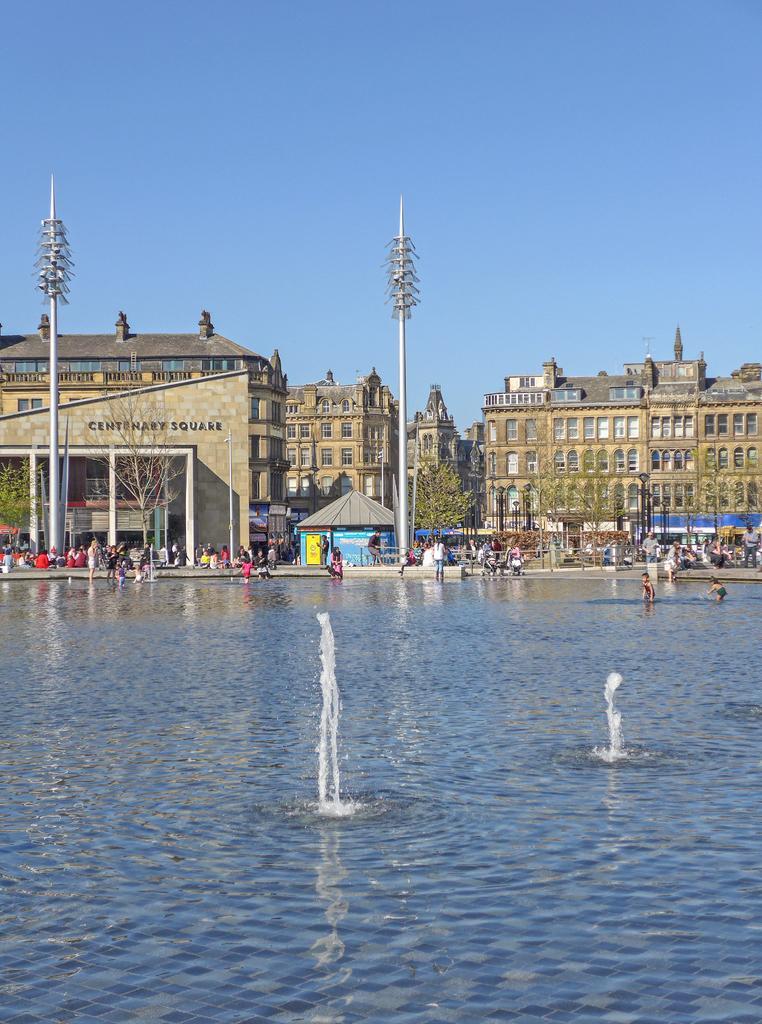Can you describe this image briefly? In this image we can see some buildings, trees, persons, poles and some other objects. At the bottom of the image there is the water, persons and other objects. At the top of the image there is the sky. 